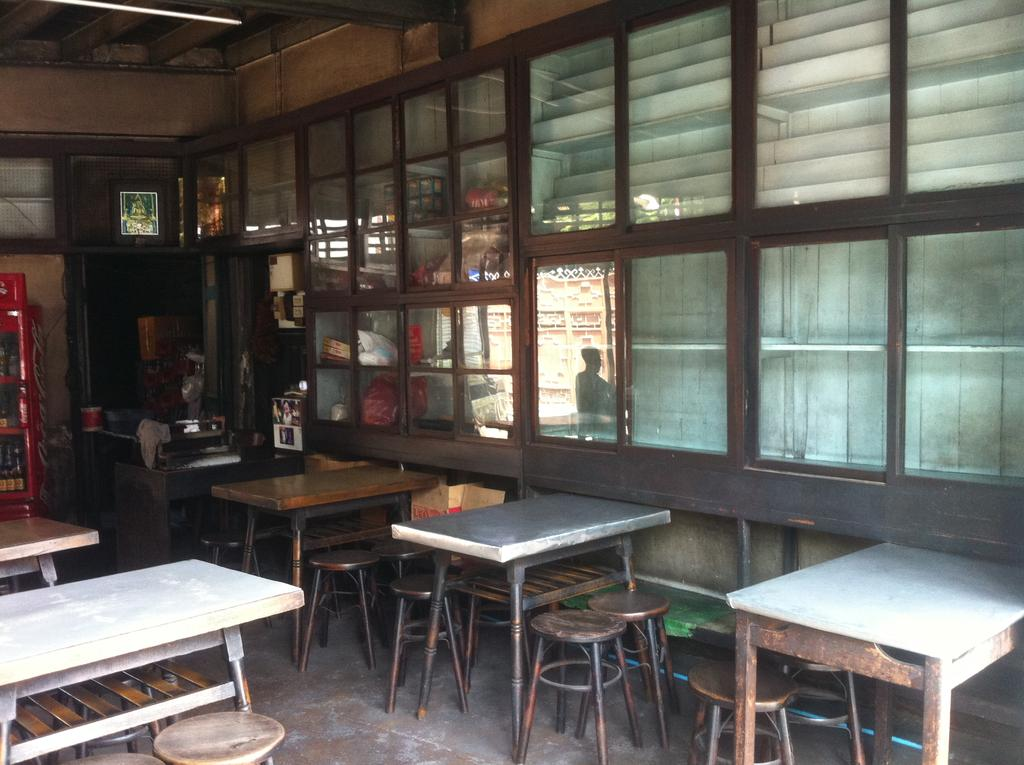What type of space is depicted in the image? The image appears to depict a hotel room. What furniture is present in the room for dining purposes? There are dining tables in the room. What type of seating is available in the room? There are chairs and stools in the room. What type of screw can be seen on the wall in the image? There is no screw visible on the wall in the image. What is the weight of the scale in the image? There is no scale present in the image. 